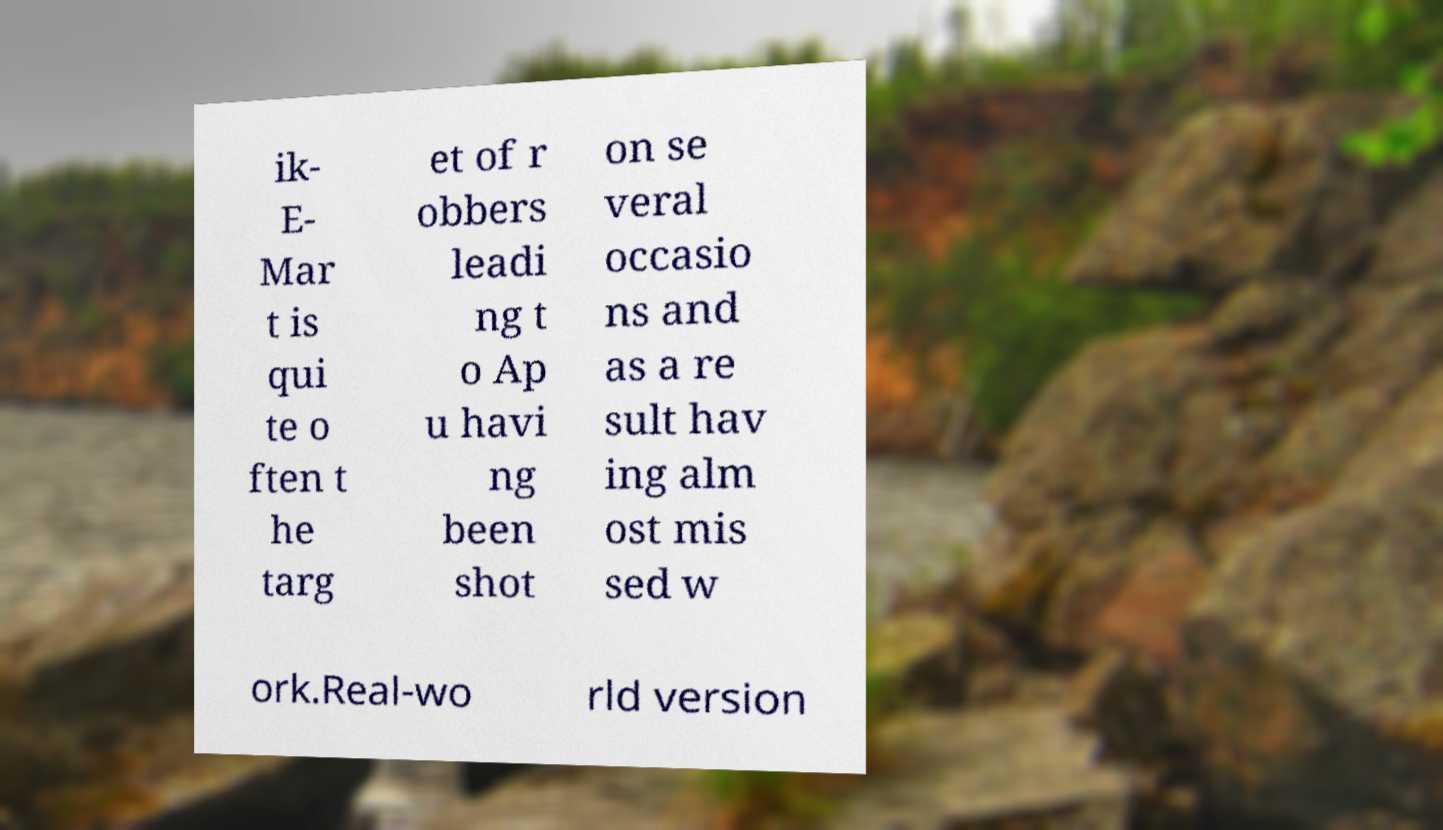What messages or text are displayed in this image? I need them in a readable, typed format. ik- E- Mar t is qui te o ften t he targ et of r obbers leadi ng t o Ap u havi ng been shot on se veral occasio ns and as a re sult hav ing alm ost mis sed w ork.Real-wo rld version 